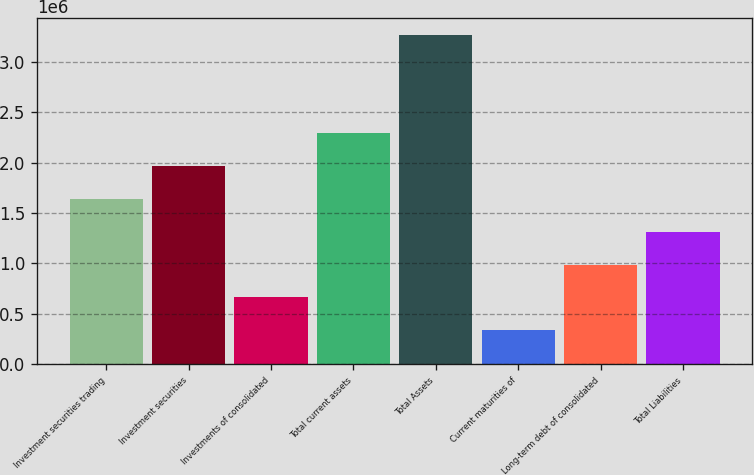<chart> <loc_0><loc_0><loc_500><loc_500><bar_chart><fcel>Investment securities trading<fcel>Investment securities<fcel>Investments of consolidated<fcel>Total current assets<fcel>Total Assets<fcel>Current maturities of<fcel>Long-term debt of consolidated<fcel>Total Liabilities<nl><fcel>1.63996e+06<fcel>1.96598e+06<fcel>661922<fcel>2.29199e+06<fcel>3.27003e+06<fcel>335908<fcel>987936<fcel>1.31395e+06<nl></chart> 